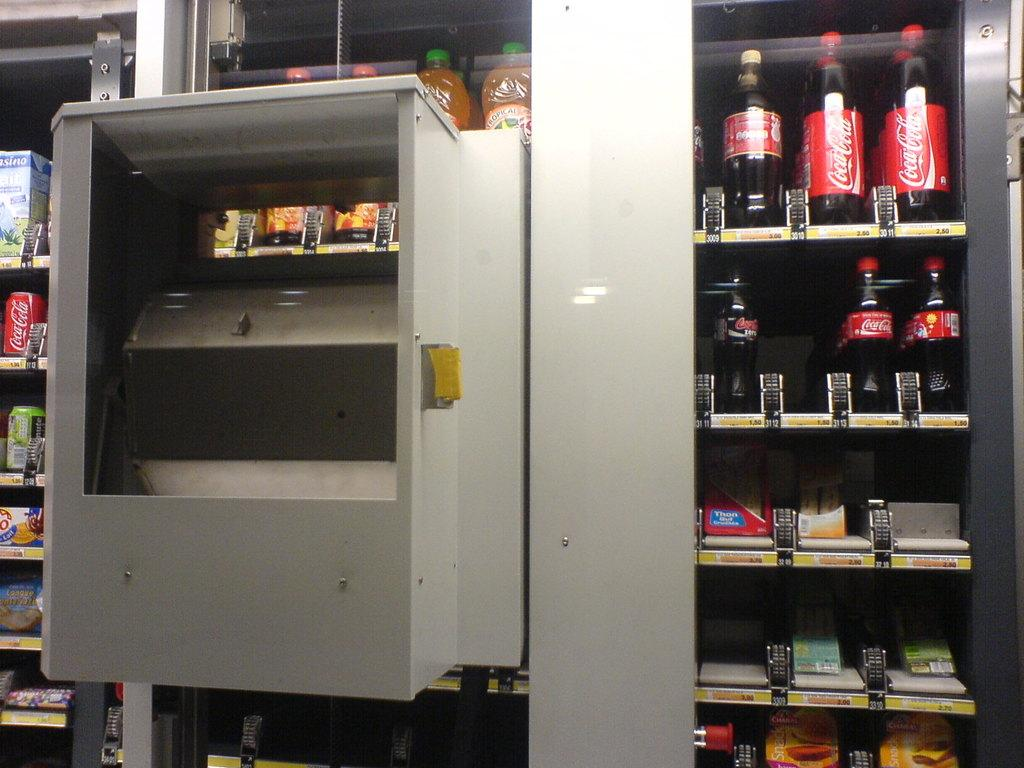<image>
Give a short and clear explanation of the subsequent image. The only soda option is for Coca Cola in the vending machine displayed. 